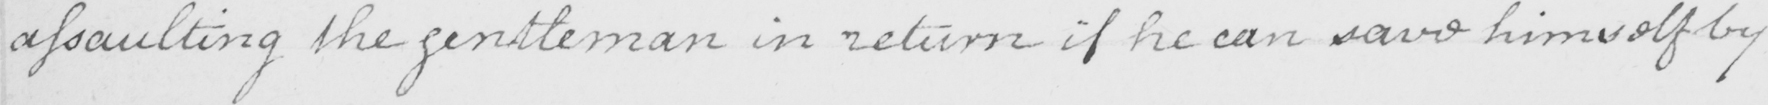What text is written in this handwritten line? assaulting the gentleman in return if he can save himself by 